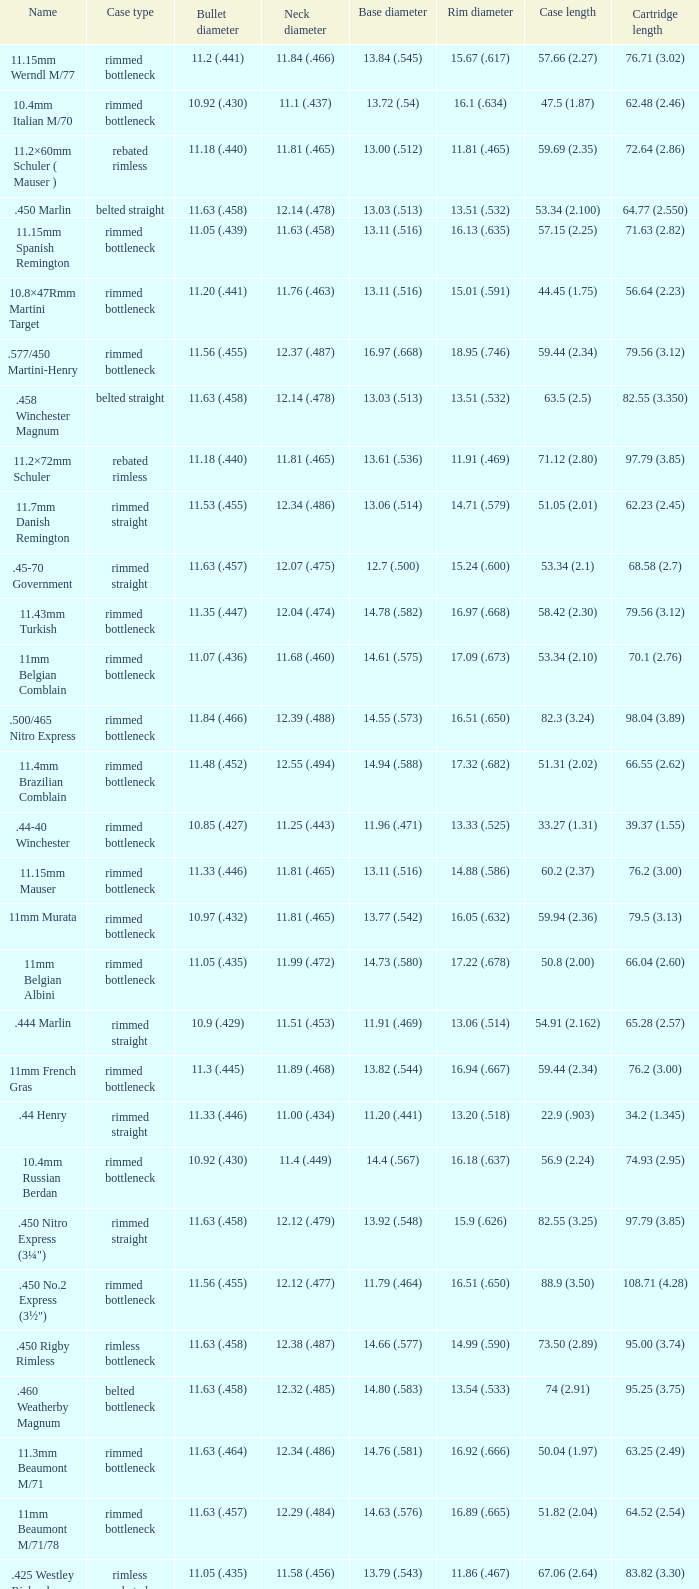Which Case type has a Cartridge length of 64.77 (2.550)? Belted straight. 